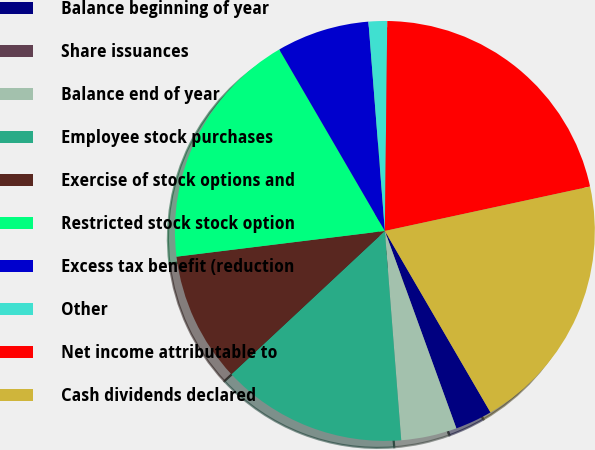<chart> <loc_0><loc_0><loc_500><loc_500><pie_chart><fcel>Balance beginning of year<fcel>Share issuances<fcel>Balance end of year<fcel>Employee stock purchases<fcel>Exercise of stock options and<fcel>Restricted stock stock option<fcel>Excess tax benefit (reduction<fcel>Other<fcel>Net income attributable to<fcel>Cash dividends declared<nl><fcel>2.86%<fcel>0.0%<fcel>4.29%<fcel>14.29%<fcel>10.0%<fcel>18.57%<fcel>7.14%<fcel>1.43%<fcel>21.43%<fcel>20.0%<nl></chart> 